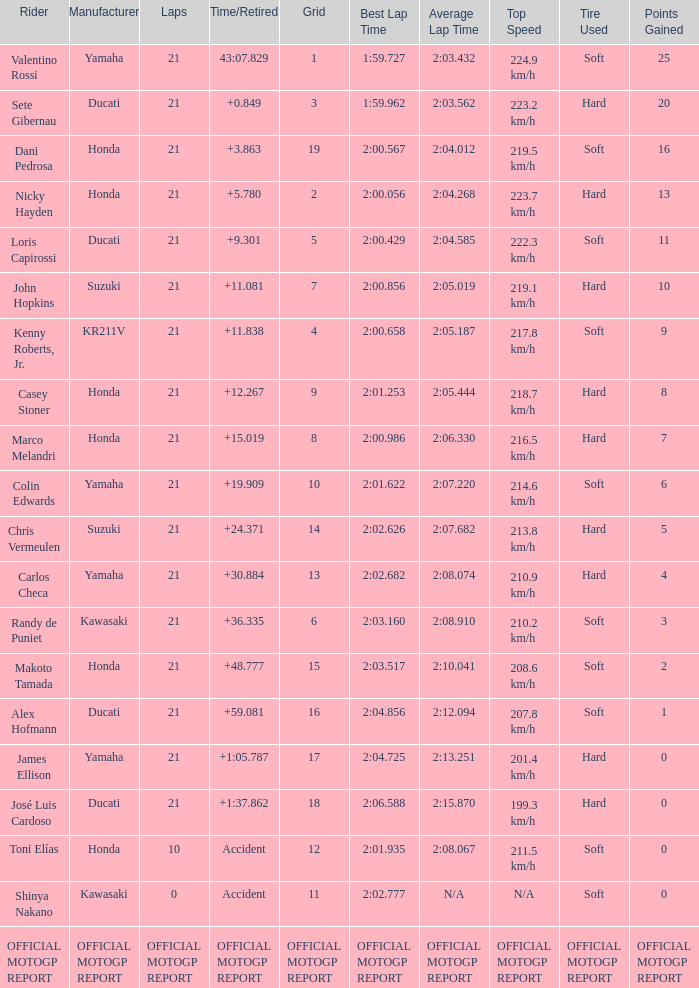Would you be able to parse every entry in this table? {'header': ['Rider', 'Manufacturer', 'Laps', 'Time/Retired', 'Grid', 'Best Lap Time', 'Average Lap Time', 'Top Speed', 'Tire Used', 'Points Gained'], 'rows': [['Valentino Rossi', 'Yamaha', '21', '43:07.829', '1', '1:59.727', '2:03.432', '224.9 km/h', 'Soft', '25'], ['Sete Gibernau', 'Ducati', '21', '+0.849', '3', '1:59.962', '2:03.562', '223.2 km/h', 'Hard', '20'], ['Dani Pedrosa', 'Honda', '21', '+3.863', '19', '2:00.567', '2:04.012', '219.5 km/h', 'Soft', '16'], ['Nicky Hayden', 'Honda', '21', '+5.780', '2', '2:00.056', '2:04.268', '223.7 km/h', 'Hard', '13'], ['Loris Capirossi', 'Ducati', '21', '+9.301', '5', '2:00.429', '2:04.585', '222.3 km/h', 'Soft', '11'], ['John Hopkins', 'Suzuki', '21', '+11.081', '7', '2:00.856', '2:05.019', '219.1 km/h', 'Hard', '10'], ['Kenny Roberts, Jr.', 'KR211V', '21', '+11.838', '4', '2:00.658', '2:05.187', '217.8 km/h', 'Soft', '9'], ['Casey Stoner', 'Honda', '21', '+12.267', '9', '2:01.253', '2:05.444', '218.7 km/h', 'Hard', '8'], ['Marco Melandri', 'Honda', '21', '+15.019', '8', '2:00.986', '2:06.330', '216.5 km/h', 'Hard', '7'], ['Colin Edwards', 'Yamaha', '21', '+19.909', '10', '2:01.622', '2:07.220', '214.6 km/h', 'Soft', '6'], ['Chris Vermeulen', 'Suzuki', '21', '+24.371', '14', '2:02.626', '2:07.682', '213.8 km/h', 'Hard', '5'], ['Carlos Checa', 'Yamaha', '21', '+30.884', '13', '2:02.682', '2:08.074', '210.9 km/h', 'Hard', '4'], ['Randy de Puniet', 'Kawasaki', '21', '+36.335', '6', '2:03.160', '2:08.910', '210.2 km/h', 'Soft', '3'], ['Makoto Tamada', 'Honda', '21', '+48.777', '15', '2:03.517', '2:10.041', '208.6 km/h', 'Soft', '2'], ['Alex Hofmann', 'Ducati', '21', '+59.081', '16', '2:04.856', '2:12.094', '207.8 km/h', 'Soft', '1'], ['James Ellison', 'Yamaha', '21', '+1:05.787', '17', '2:04.725', '2:13.251', '201.4 km/h', 'Hard', '0'], ['José Luis Cardoso', 'Ducati', '21', '+1:37.862', '18', '2:06.588', '2:15.870', '199.3 km/h', 'Hard', '0'], ['Toni Elías', 'Honda', '10', 'Accident', '12', '2:01.935', '2:08.067', '211.5 km/h', 'Soft', '0'], ['Shinya Nakano', 'Kawasaki', '0', 'Accident', '11', '2:02.777', 'N/A', 'N/A', 'Soft', '0'], ['OFFICIAL MOTOGP REPORT', 'OFFICIAL MOTOGP REPORT', 'OFFICIAL MOTOGP REPORT', 'OFFICIAL MOTOGP REPORT', 'OFFICIAL MOTOGP REPORT', 'OFFICIAL MOTOGP REPORT', 'OFFICIAL MOTOGP REPORT', 'OFFICIAL MOTOGP REPORT', 'OFFICIAL MOTOGP REPORT', 'OFFICIAL MOTOGP REPORT']]} Which rider had a time/retired od +19.909? Colin Edwards. 